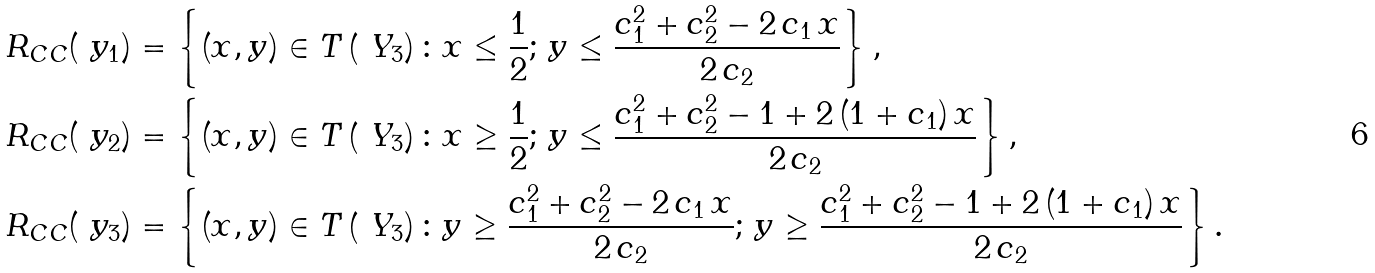Convert formula to latex. <formula><loc_0><loc_0><loc_500><loc_500>R _ { C C } ( \ y _ { 1 } ) & = \left \{ ( x , y ) \in T \left ( \ Y _ { 3 } \right ) \colon x \leq \frac { 1 } { 2 } ; \, y \leq \frac { c _ { 1 } ^ { 2 } + c _ { 2 } ^ { 2 } - 2 \, c _ { 1 } \, x } { 2 \, c _ { 2 } } \right \} , \\ R _ { C C } ( \ y _ { 2 } ) & = \left \{ ( x , y ) \in T \left ( \ Y _ { 3 } \right ) \colon x \geq \frac { 1 } { 2 } ; \, y \leq \frac { c _ { 1 } ^ { 2 } + c _ { 2 } ^ { 2 } - 1 + 2 \, ( 1 + c _ { 1 } ) \, x } { 2 \, c _ { 2 } } \right \} , \\ R _ { C C } ( \ y _ { 3 } ) & = \left \{ ( x , y ) \in T \left ( \ Y _ { 3 } \right ) \colon y \geq \frac { c _ { 1 } ^ { 2 } + c _ { 2 } ^ { 2 } - 2 \, c _ { 1 } \, x } { 2 \, c _ { 2 } } ; \, y \geq \frac { c _ { 1 } ^ { 2 } + c _ { 2 } ^ { 2 } - 1 + 2 \, ( 1 + c _ { 1 } ) \, x } { 2 \, c _ { 2 } } \right \} .</formula> 